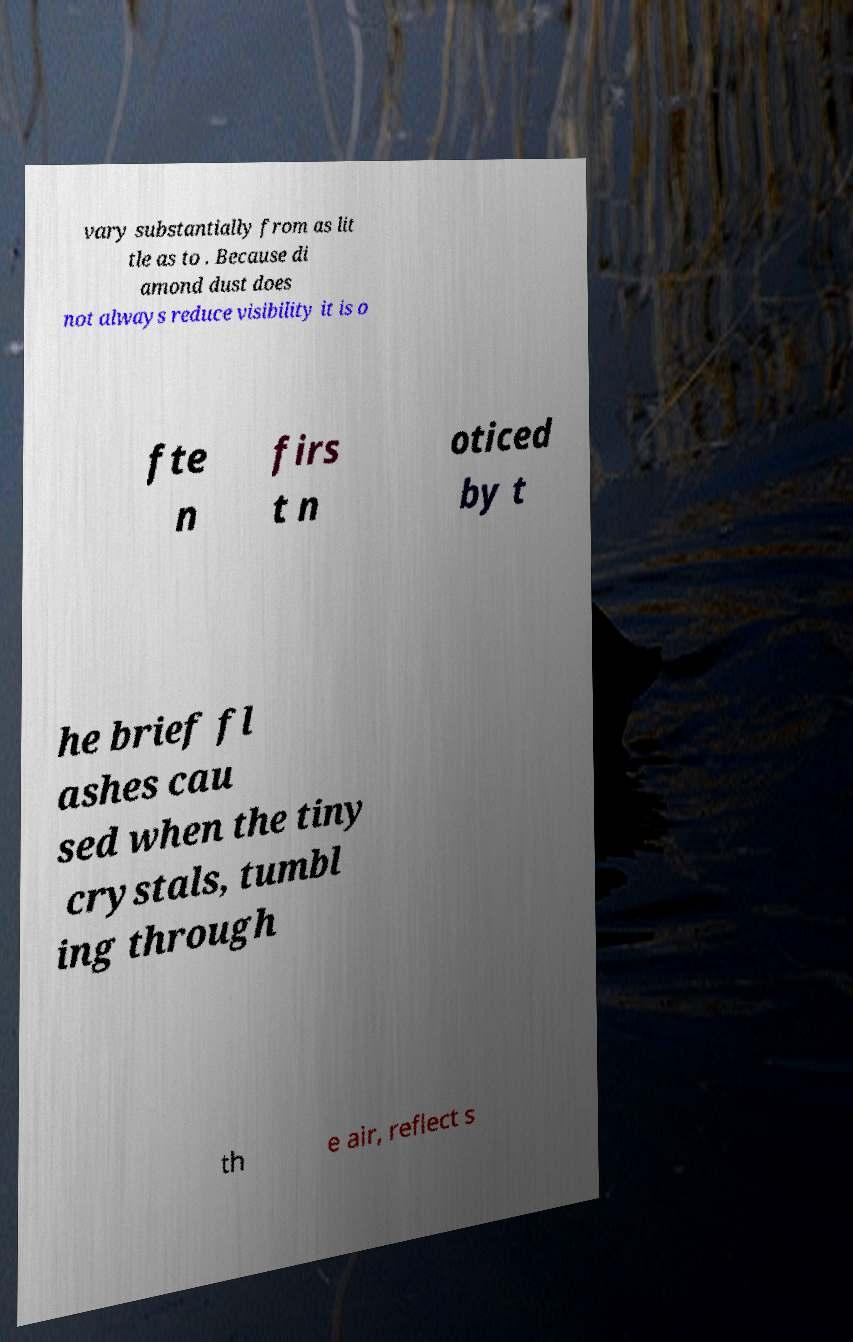Could you assist in decoding the text presented in this image and type it out clearly? vary substantially from as lit tle as to . Because di amond dust does not always reduce visibility it is o fte n firs t n oticed by t he brief fl ashes cau sed when the tiny crystals, tumbl ing through th e air, reflect s 